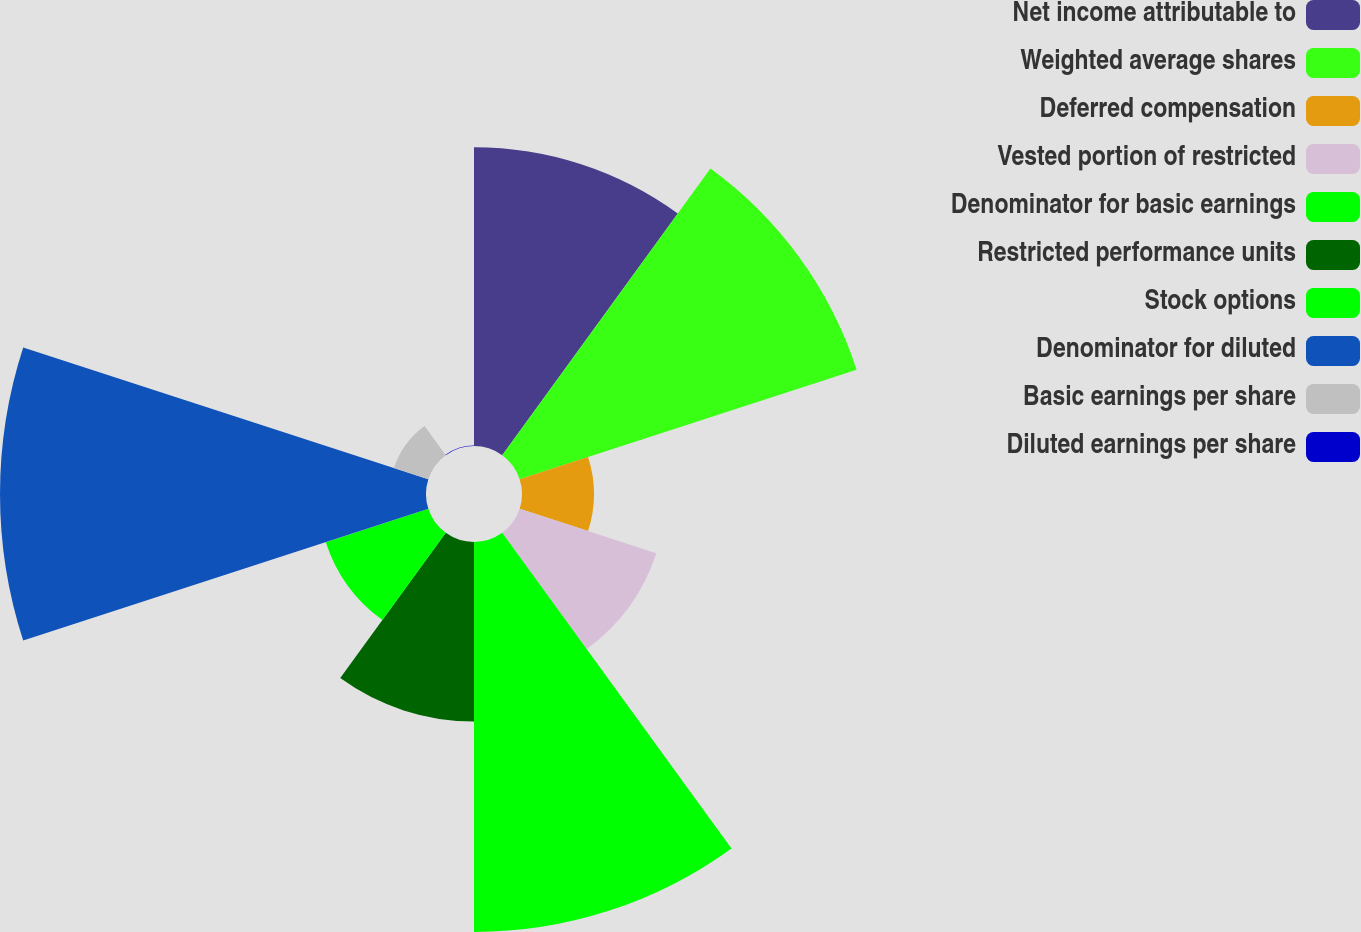<chart> <loc_0><loc_0><loc_500><loc_500><pie_chart><fcel>Net income attributable to<fcel>Weighted average shares<fcel>Deferred compensation<fcel>Vested portion of restricted<fcel>Denominator for basic earnings<fcel>Restricted performance units<fcel>Stock options<fcel>Denominator for diluted<fcel>Basic earnings per share<fcel>Diluted earnings per share<nl><fcel>14.87%<fcel>17.64%<fcel>3.58%<fcel>7.15%<fcel>19.42%<fcel>8.94%<fcel>5.37%<fcel>21.21%<fcel>1.8%<fcel>0.02%<nl></chart> 